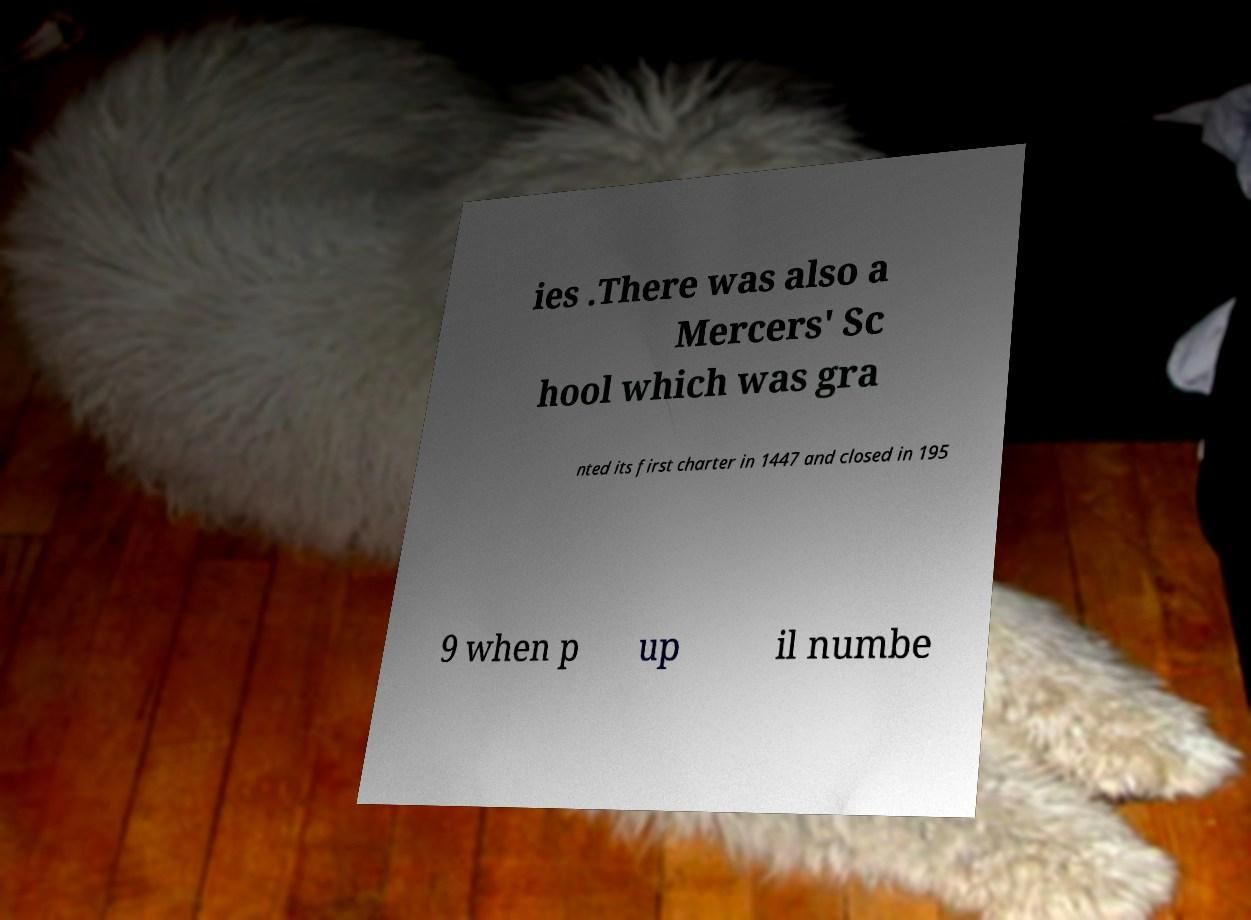Could you assist in decoding the text presented in this image and type it out clearly? ies .There was also a Mercers' Sc hool which was gra nted its first charter in 1447 and closed in 195 9 when p up il numbe 